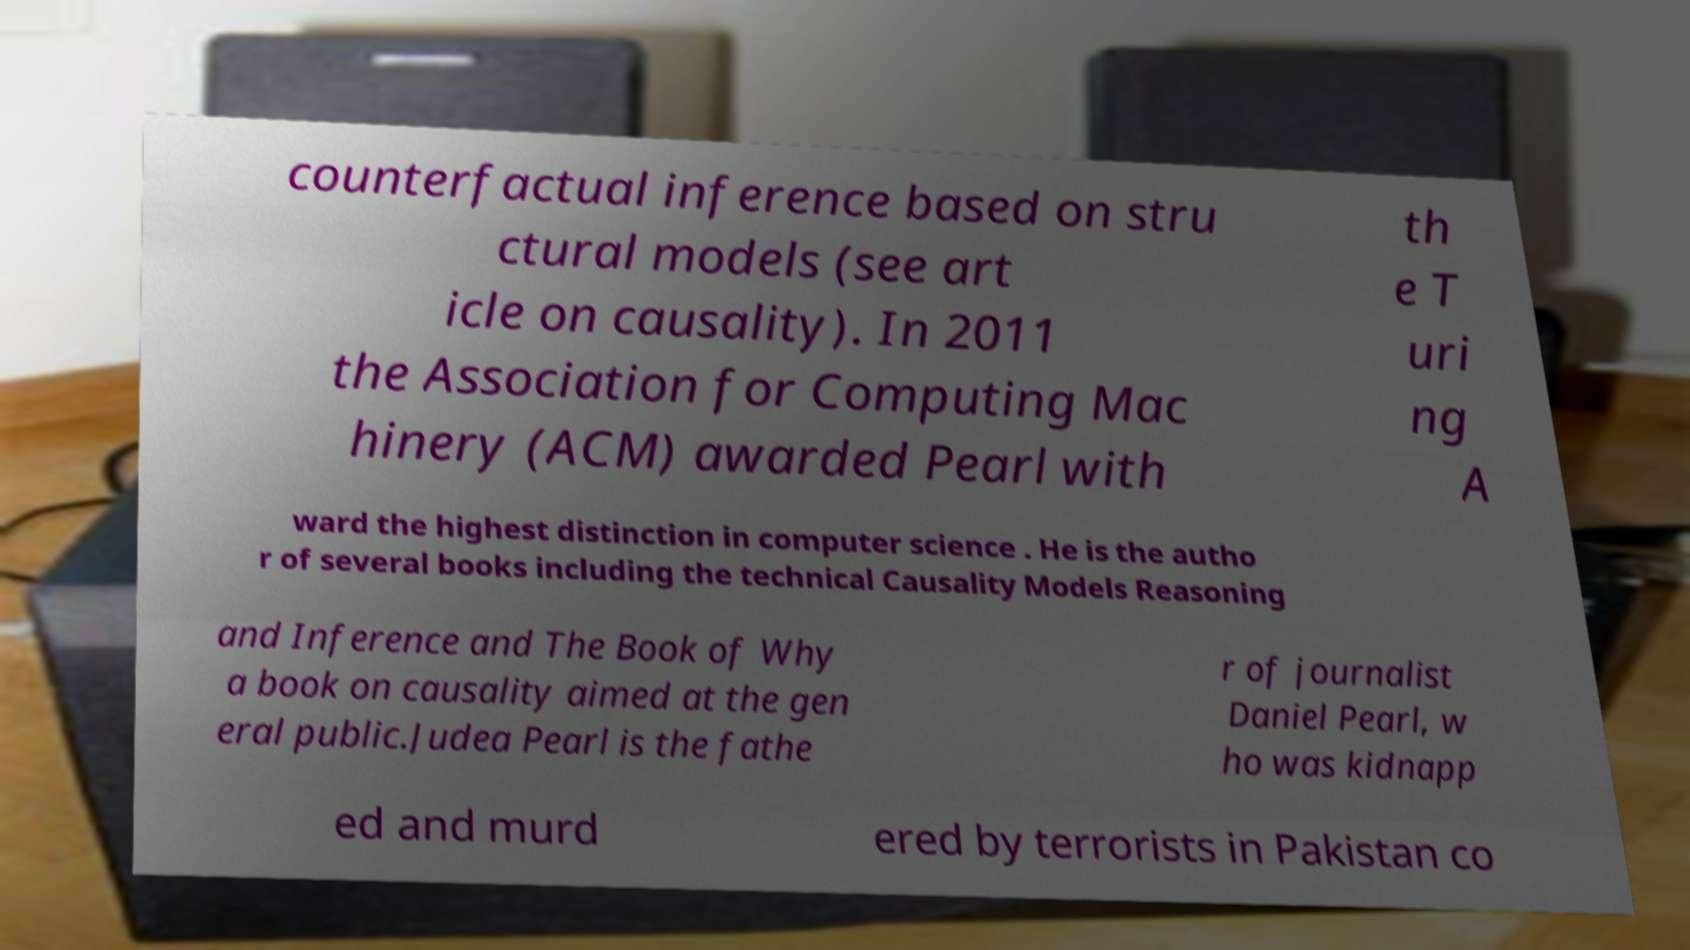Please read and relay the text visible in this image. What does it say? counterfactual inference based on stru ctural models (see art icle on causality). In 2011 the Association for Computing Mac hinery (ACM) awarded Pearl with th e T uri ng A ward the highest distinction in computer science . He is the autho r of several books including the technical Causality Models Reasoning and Inference and The Book of Why a book on causality aimed at the gen eral public.Judea Pearl is the fathe r of journalist Daniel Pearl, w ho was kidnapp ed and murd ered by terrorists in Pakistan co 